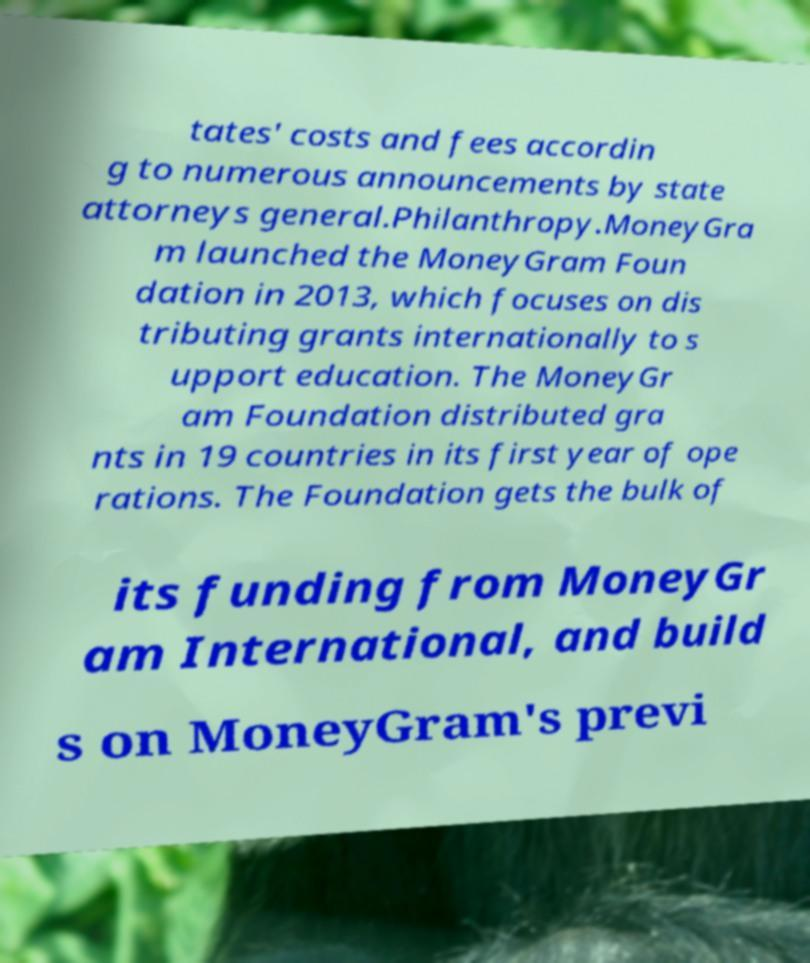Can you read and provide the text displayed in the image?This photo seems to have some interesting text. Can you extract and type it out for me? tates' costs and fees accordin g to numerous announcements by state attorneys general.Philanthropy.MoneyGra m launched the MoneyGram Foun dation in 2013, which focuses on dis tributing grants internationally to s upport education. The MoneyGr am Foundation distributed gra nts in 19 countries in its first year of ope rations. The Foundation gets the bulk of its funding from MoneyGr am International, and build s on MoneyGram's previ 